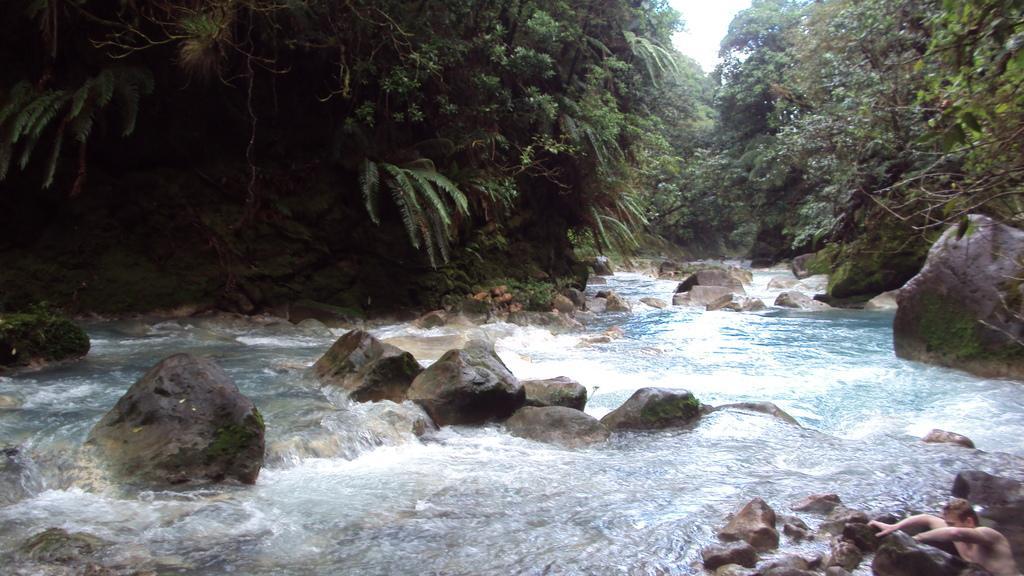Describe this image in one or two sentences. In this image I can see the water and there are many rocks in it. To the side of the water I can see many trees and there is a white sky in the back. 